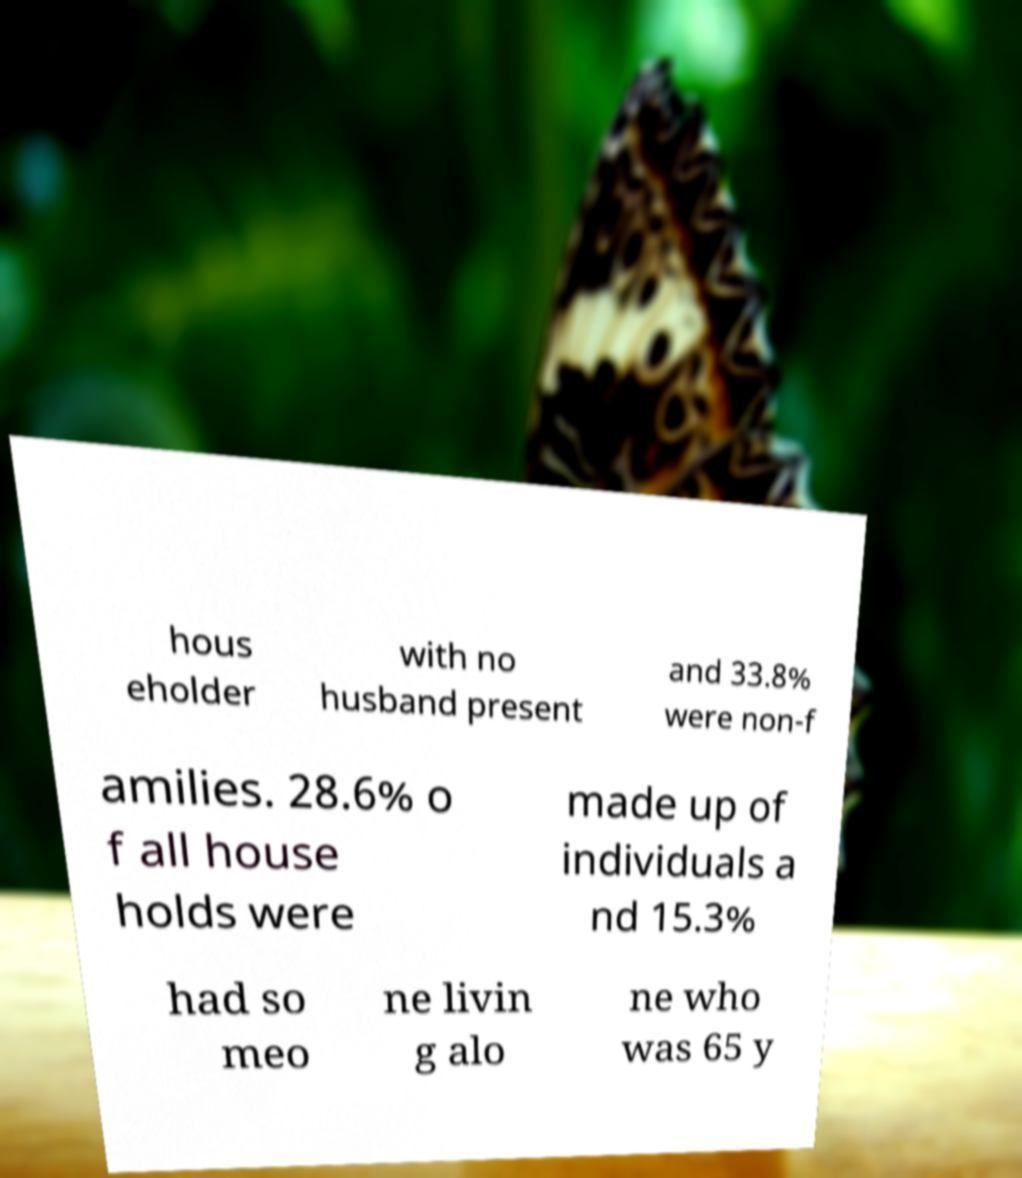There's text embedded in this image that I need extracted. Can you transcribe it verbatim? hous eholder with no husband present and 33.8% were non-f amilies. 28.6% o f all house holds were made up of individuals a nd 15.3% had so meo ne livin g alo ne who was 65 y 